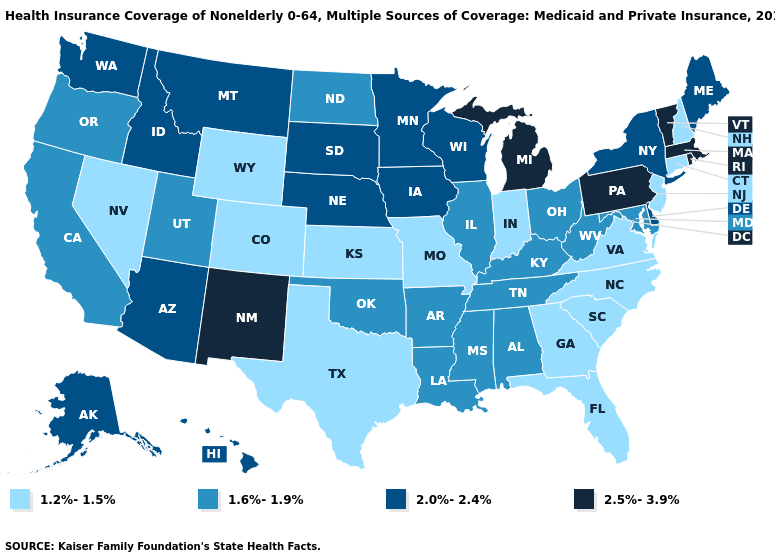Is the legend a continuous bar?
Give a very brief answer. No. What is the lowest value in states that border Texas?
Write a very short answer. 1.6%-1.9%. Does Mississippi have the same value as California?
Answer briefly. Yes. What is the lowest value in the South?
Keep it brief. 1.2%-1.5%. Name the states that have a value in the range 2.0%-2.4%?
Answer briefly. Alaska, Arizona, Delaware, Hawaii, Idaho, Iowa, Maine, Minnesota, Montana, Nebraska, New York, South Dakota, Washington, Wisconsin. Does Alaska have the highest value in the USA?
Concise answer only. No. Does Delaware have the highest value in the South?
Be succinct. Yes. What is the value of Oklahoma?
Short answer required. 1.6%-1.9%. What is the lowest value in states that border North Carolina?
Give a very brief answer. 1.2%-1.5%. Name the states that have a value in the range 1.2%-1.5%?
Give a very brief answer. Colorado, Connecticut, Florida, Georgia, Indiana, Kansas, Missouri, Nevada, New Hampshire, New Jersey, North Carolina, South Carolina, Texas, Virginia, Wyoming. Does Utah have the highest value in the West?
Quick response, please. No. What is the value of Washington?
Answer briefly. 2.0%-2.4%. Name the states that have a value in the range 1.6%-1.9%?
Short answer required. Alabama, Arkansas, California, Illinois, Kentucky, Louisiana, Maryland, Mississippi, North Dakota, Ohio, Oklahoma, Oregon, Tennessee, Utah, West Virginia. Does Georgia have the lowest value in the USA?
Give a very brief answer. Yes. What is the lowest value in the USA?
Keep it brief. 1.2%-1.5%. 